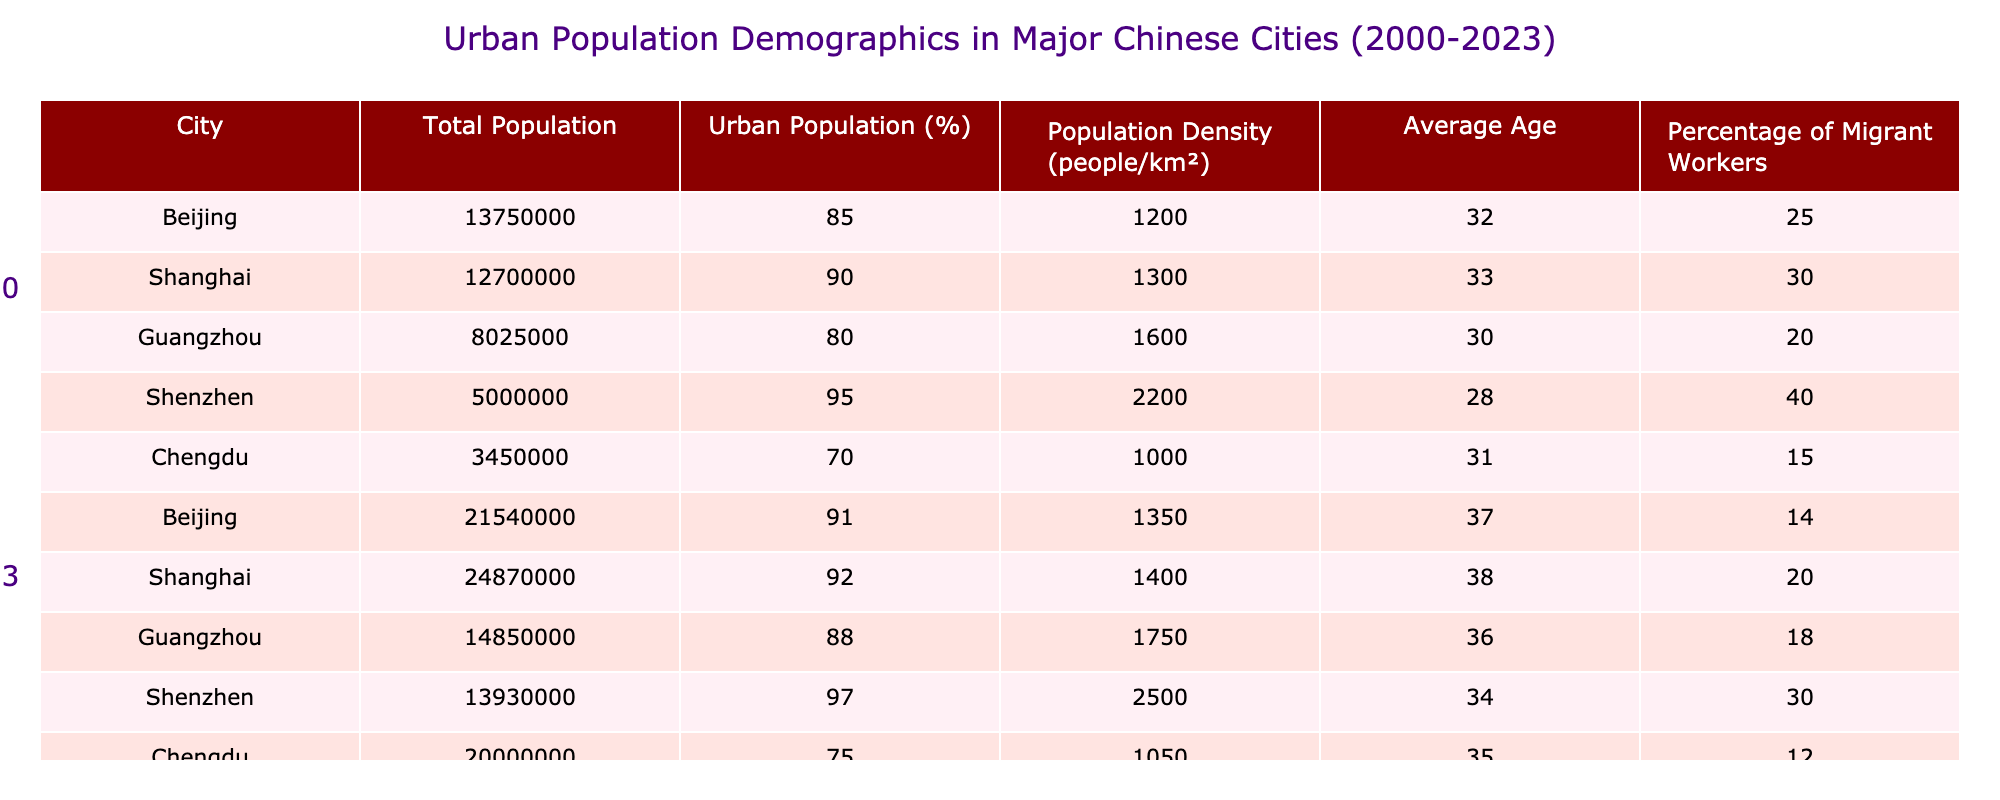What was the total population of Shanghai in 2023? In the table, under the column for the year 2023, find the row for Shanghai. The corresponding value in the Total Population column is 24,870,000.
Answer: 24,870,000 What is the percentage of urban population in Guangzhou in 2000? In the table, locate the row for Guangzhou in the year 2000. The Urban Population (%) for that year is 80%.
Answer: 80% Did the average age of the population in Shenzhen increase from 2000 to 2023? For Shenzhen in 2000, the Average Age is 28, and in 2023 it is 34. Since 34 is greater than 28, the average age did indeed increase.
Answer: Yes What was the change in the percentage of migrant workers in Beijing from 2000 to 2023? The percentage of migrant workers in Beijing in 2000 was 25%, and in 2023 it dropped to 14%. The change can be calculated as 25% - 14% = 11%. Thus, there was a decrease of 11 percentage points.
Answer: Decrease of 11 percentage points Which city had the highest population density in 2023 and what was that density? In the year 2023, compare the Population Density values across all cities. Shenzhen has the highest density at 2,500 people/km².
Answer: Shenzhen, 2500 people/km² What is the average urban population percentage across all cities in 2023? In 2023, the Urban Population percentages are 91% (Beijing), 92% (Shanghai), 88% (Guangzhou), 97% (Shenzhen), and 75% (Chengdu). Adding these percentages gives 91 + 92 + 88 + 97 + 75 = 443. Dividing by 5 (the number of cities) gives an average of 443/5 = 88.6%.
Answer: 88.6% Is it true that the total population of Chengdu increased from 2000 to 2023? The total population of Chengdu in 2000 is 3,450,000 and in 2023 it is 20,000,000. Since 20,000,000 is greater than 3,450,000, the statement is true.
Answer: Yes What was the percentage change in urban population in Guangzhou from 2000 to 2023? The urban population percentage in Guangzhou in 2000 was 80%, and in 2023 it was 88%. The percentage change can be calculated as (88% - 80%) / 80% * 100 = 10%. Hence, the urban population percentage increased by 10%.
Answer: 10% increase 